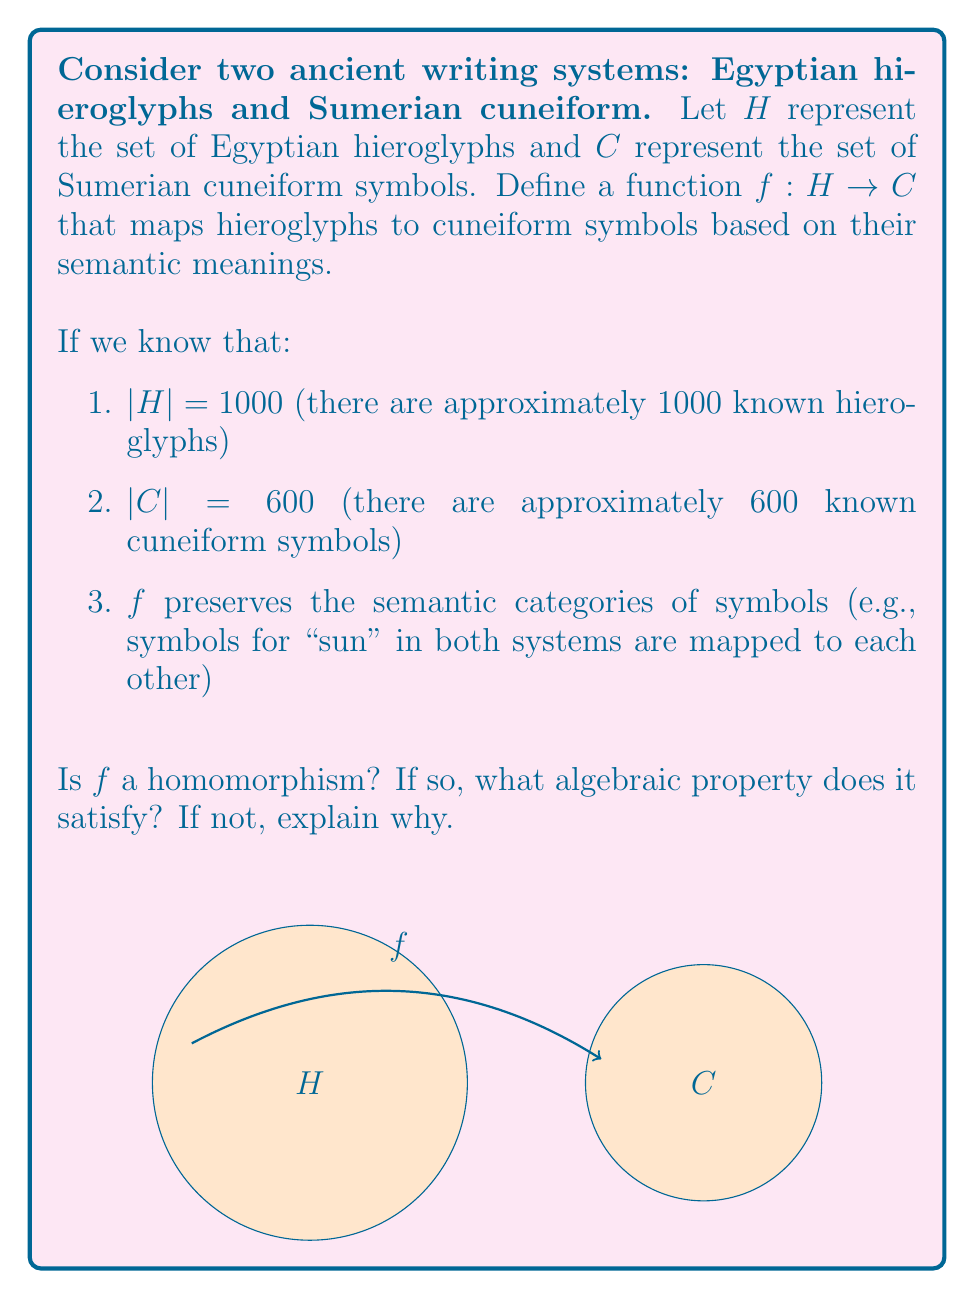What is the answer to this math problem? To determine if $f$ is a homomorphism, we need to examine its properties:

1. Domain and Codomain:
   The function $f$ maps from $H$ to $C$, which are both sets of symbols. This satisfies the basic requirement of a function.

2. Preservation of Structure:
   For $f$ to be a homomorphism, it needs to preserve some algebraic structure between $H$ and $C$. In this case, we're told that $f$ preserves semantic categories.

3. Surjectivity:
   Since $|H| > |C|$, $f$ could potentially be surjective (onto), meaning every element in $C$ has at least one preimage in $H$.

4. Injectivity:
   Given that $|H| > |C|$, $f$ cannot be injective (one-to-one). Multiple hieroglyphs may map to the same cuneiform symbol.

5. Algebraic Property:
   The preservation of semantic categories suggests that $f$ satisfies the property:

   $$f(a \cdot b) = f(a) \star f(b)$$

   Where $\cdot$ represents the combination of meanings in hieroglyphs and $\star$ represents the combination of meanings in cuneiform.

This property is characteristic of a homomorphism in abstract algebra. It shows that the function preserves the "multiplication" (in this case, combination of meanings) between the two systems.

Therefore, $f$ is indeed a homomorphism. It satisfies the key property of preserving structure between the two writing systems, specifically the semantic relationships between symbols.
Answer: Yes, $f$ is a homomorphism satisfying $f(a \cdot b) = f(a) \star f(b)$. 